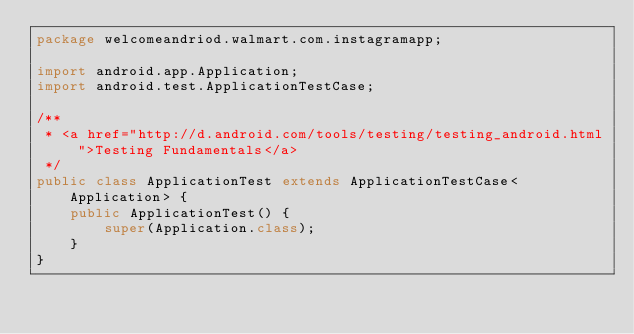Convert code to text. <code><loc_0><loc_0><loc_500><loc_500><_Java_>package welcomeandriod.walmart.com.instagramapp;

import android.app.Application;
import android.test.ApplicationTestCase;

/**
 * <a href="http://d.android.com/tools/testing/testing_android.html">Testing Fundamentals</a>
 */
public class ApplicationTest extends ApplicationTestCase<Application> {
    public ApplicationTest() {
        super(Application.class);
    }
}</code> 